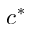Convert formula to latex. <formula><loc_0><loc_0><loc_500><loc_500>c ^ { * }</formula> 